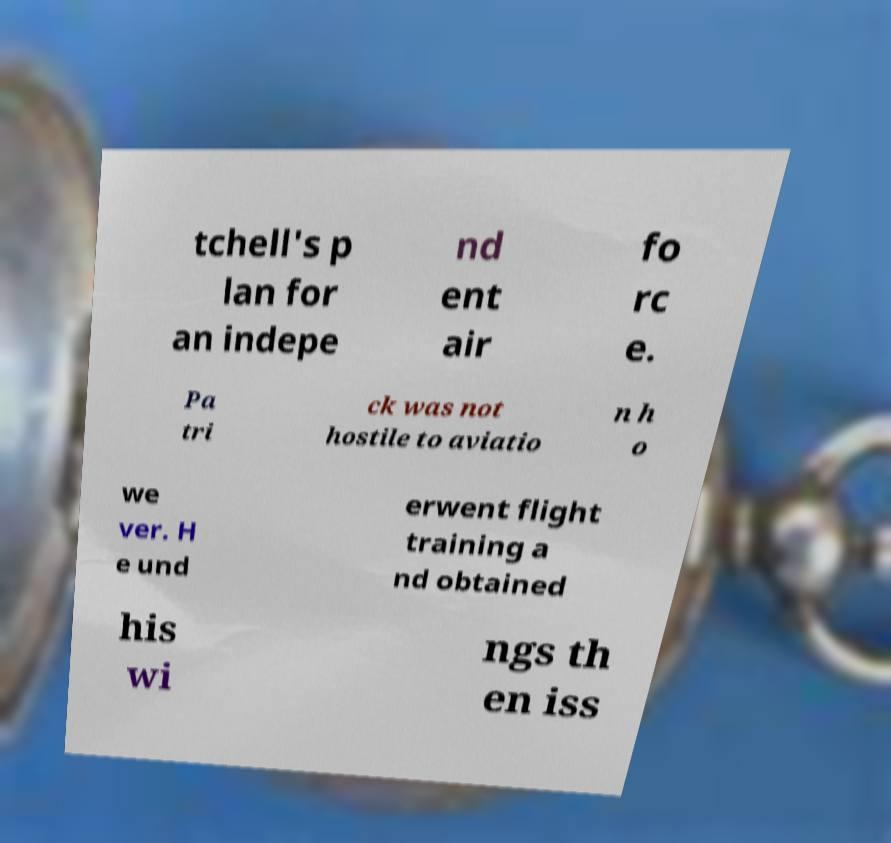Please read and relay the text visible in this image. What does it say? tchell's p lan for an indepe nd ent air fo rc e. Pa tri ck was not hostile to aviatio n h o we ver. H e und erwent flight training a nd obtained his wi ngs th en iss 